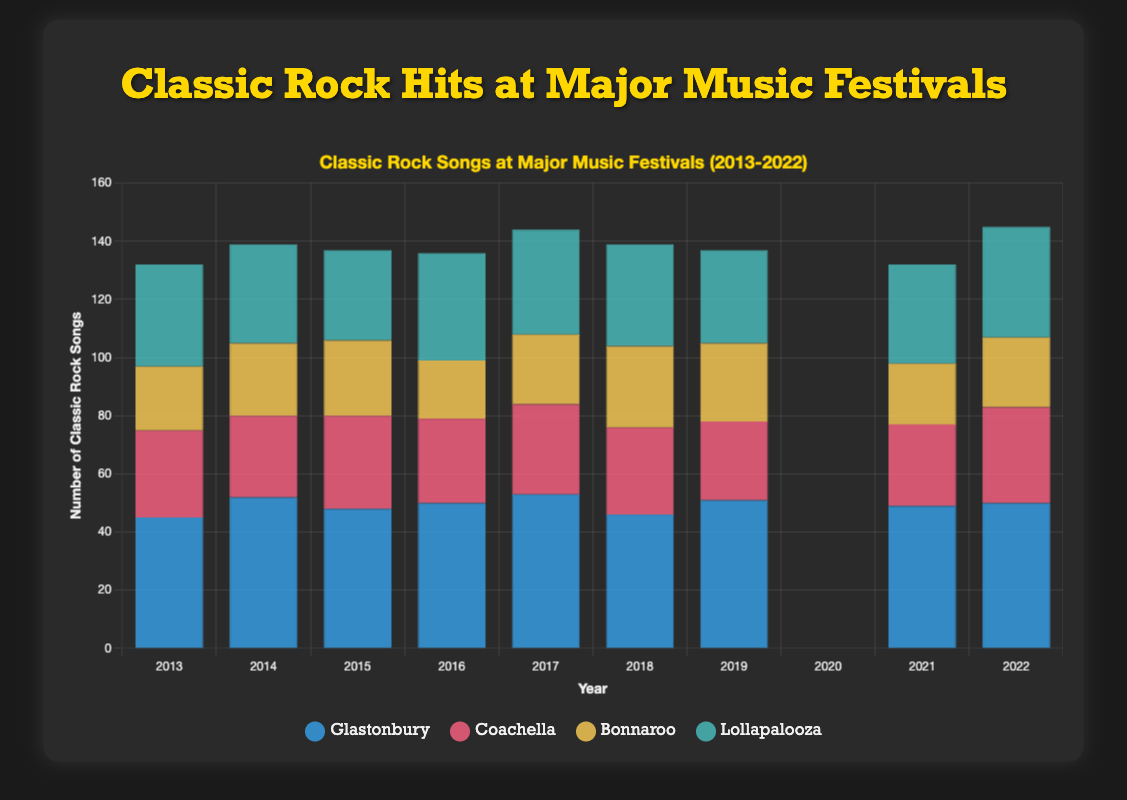Which festival has the highest number of classic rock songs performed in a single year? Look at each festival and identify the year where the number of classic rock songs is highest. Glastonbury in 2017 has the highest count of 53 songs.
Answer: Glastonbury How many classic rock songs were performed at Bonnaroo in the years 2013, 2014, and 2015 combined? Sum the number of songs performed at Bonnaroo for these three years: 22 (2013) + 25 (2014) + 26 (2015).
Answer: 73 Which festival had no classic rock songs performed in 2020? Identify the festival with zero classic rock songs for the year 2020 by looking at the bar corresponding to 2020: All listed festivals had zero classic rock songs that year.
Answer: All festivals During which years did Coachella have a number of classic rock songs performed that was less than 30? Check the number of classic rock songs for Coachella each year and identify the years where the count is less than 30: 2014 (28), 2016 (29), 2019 (27), 2021 (28).
Answer: 2014, 2016, 2019, 2021 Between Lollapalooza and Glastonbury, which festival had more classic rock songs in 2018? Compare the number of classic rock songs for Lollapalooza and Glastonbury in 2018 and conclude which is higher: Lollapalooza (35) vs Glastonbury (46).
Answer: Glastonbury What was the average number of classic rock songs performed at Coachella from 2017 to 2022 (excluding 2020)? Calculate the average excluding 2020: (31+30+27+28+33)/5 = 149/5. The average is 29.8.
Answer: 29.8 Which festival had the largest increase in the number of classic rock songs performed between any two consecutive years? Find the difference between consecutive years for each festival and identify the largest increase: Glastonbury from 2013 to 2014 had an increase from 45 to 52, which is an increase of 7.
Answer: Glastonbury Which festival showed the most consistent number of classic rock songs over the decade? Observe the number of songs and identify the festival with minimal fluctuation: Lollapalooza's numbers range mostly between 31 and 38 indicating minor fluctuations.
Answer: Lollapalooza In which year did Bonnaroo see the lowest number of classic rock songs performed, excluding 2020? Exclude 2020 and check for the lowest number in other years: The lowest is 20 in 2016.
Answer: 2016 Compare the total number of classic rock songs performed at Glastonbury and Coachella over the last 10 years (2013-2022). Which is greater? Sum the number of classic rock songs for each festival from 2013 to 2022 and compare:
Glastonbury: 45+52+48+50+53+46+51+0+49+50 = 444
Coachella: 30+28+32+29+31+30+27+0+28+33 = 268
Answer: Glastonbury 